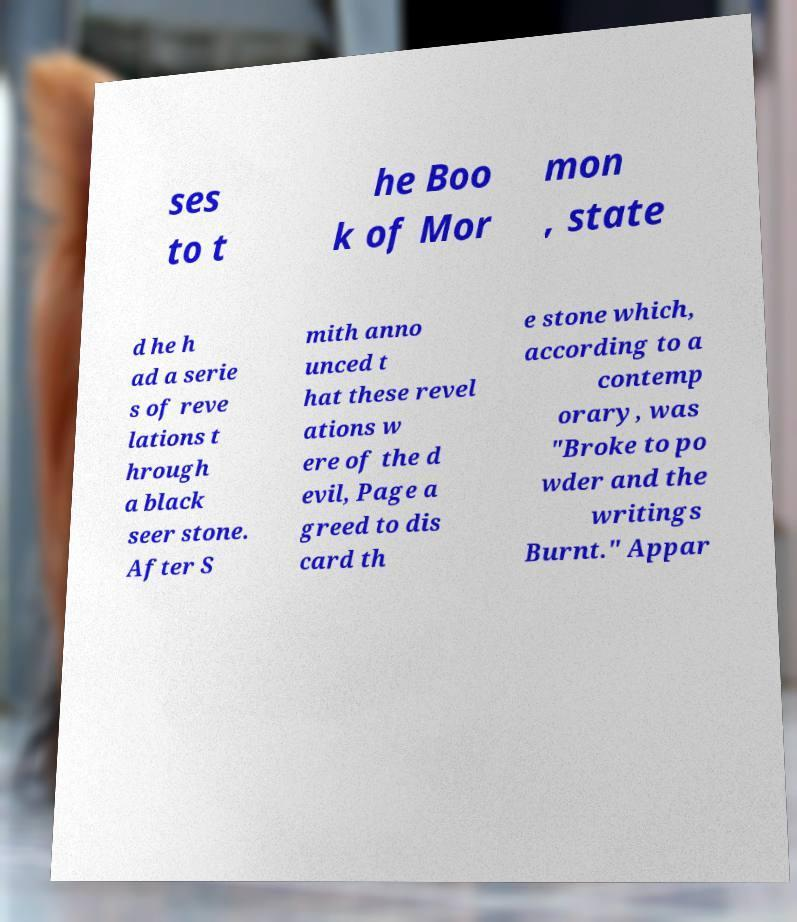Could you extract and type out the text from this image? ses to t he Boo k of Mor mon , state d he h ad a serie s of reve lations t hrough a black seer stone. After S mith anno unced t hat these revel ations w ere of the d evil, Page a greed to dis card th e stone which, according to a contemp orary, was "Broke to po wder and the writings Burnt." Appar 